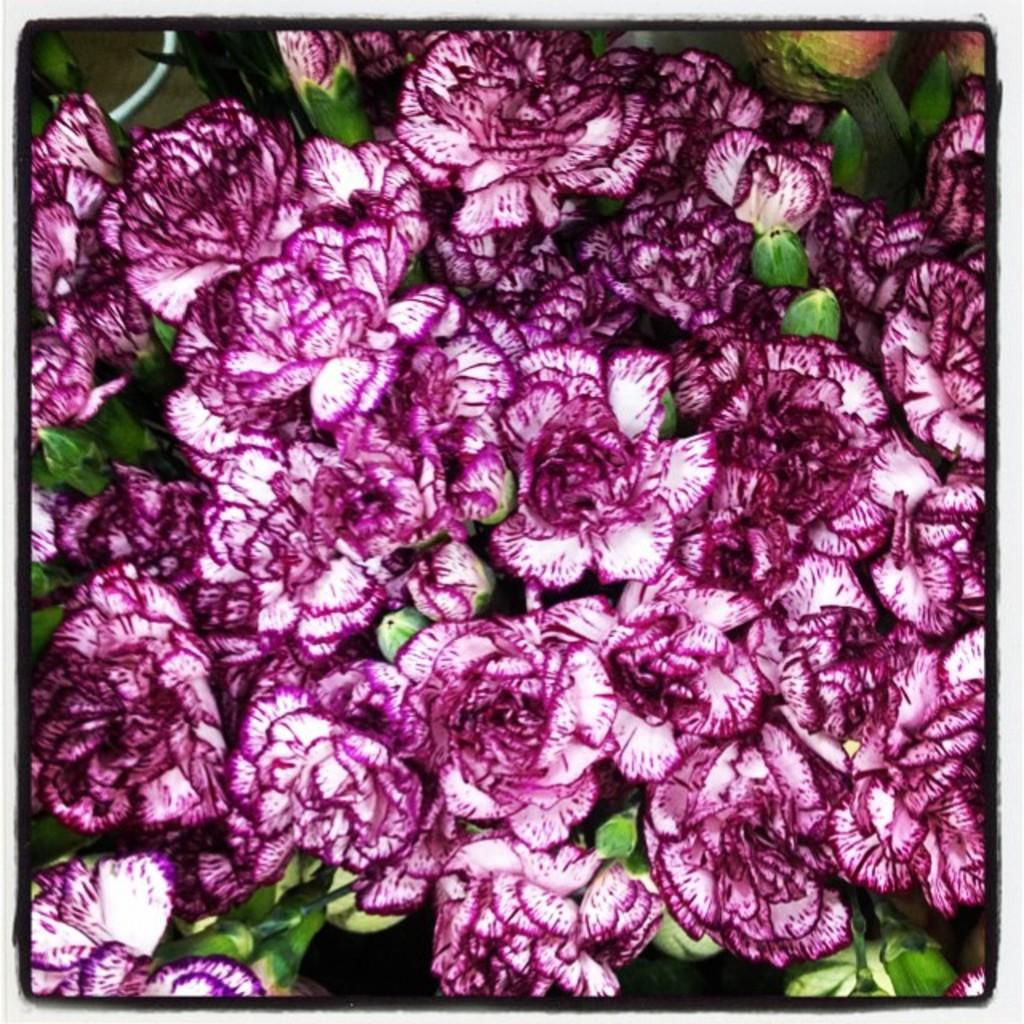What type of plant life is visible in the image? There are flowers and leaves in the image. Can you describe the flowers in the image? Unfortunately, the facts provided do not give specific details about the flowers. Are there any other elements in the image besides the flowers and leaves? The facts provided do not mention any other elements in the image. What type of glue is being used to hold the zephyr in place in the image? There is no mention of glue or a zephyr in the image, so it is not possible to answer that question. 